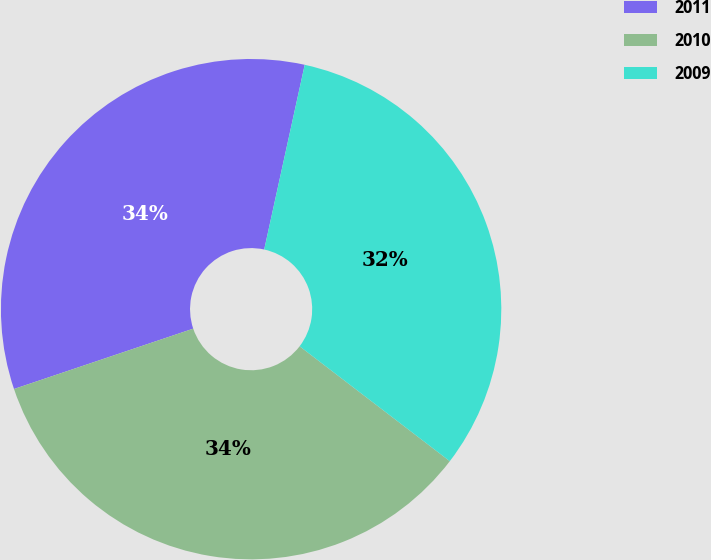<chart> <loc_0><loc_0><loc_500><loc_500><pie_chart><fcel>2011<fcel>2010<fcel>2009<nl><fcel>33.61%<fcel>34.44%<fcel>31.96%<nl></chart> 